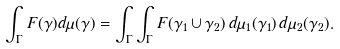<formula> <loc_0><loc_0><loc_500><loc_500>\int _ { \Gamma } F ( \gamma ) d \mu ( \gamma ) = \int _ { \Gamma } \int _ { \Gamma } F ( \gamma _ { 1 } \cup \gamma _ { 2 } ) \, d \mu _ { 1 } ( \gamma _ { 1 } ) \, d \mu _ { 2 } ( \gamma _ { 2 } ) .</formula> 